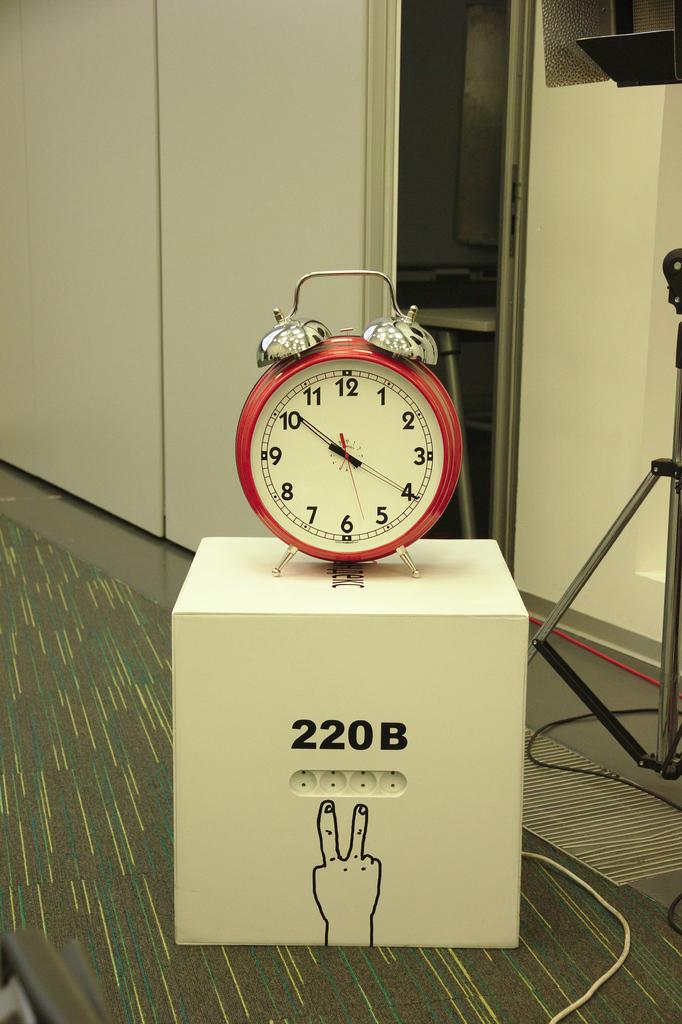What is the time on the alarm clock?
Keep it short and to the point. 10:20. What time is shown on the box?
Offer a very short reply. 10:20. 